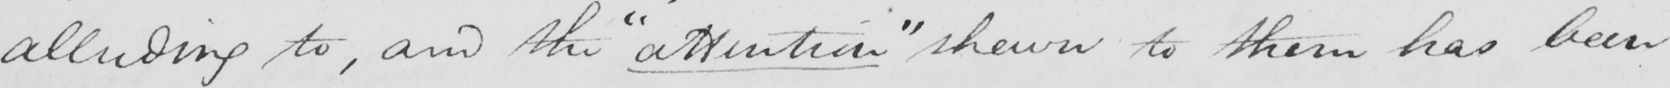Please provide the text content of this handwritten line. alluding to , and the  " attention "  shewn to them has been 